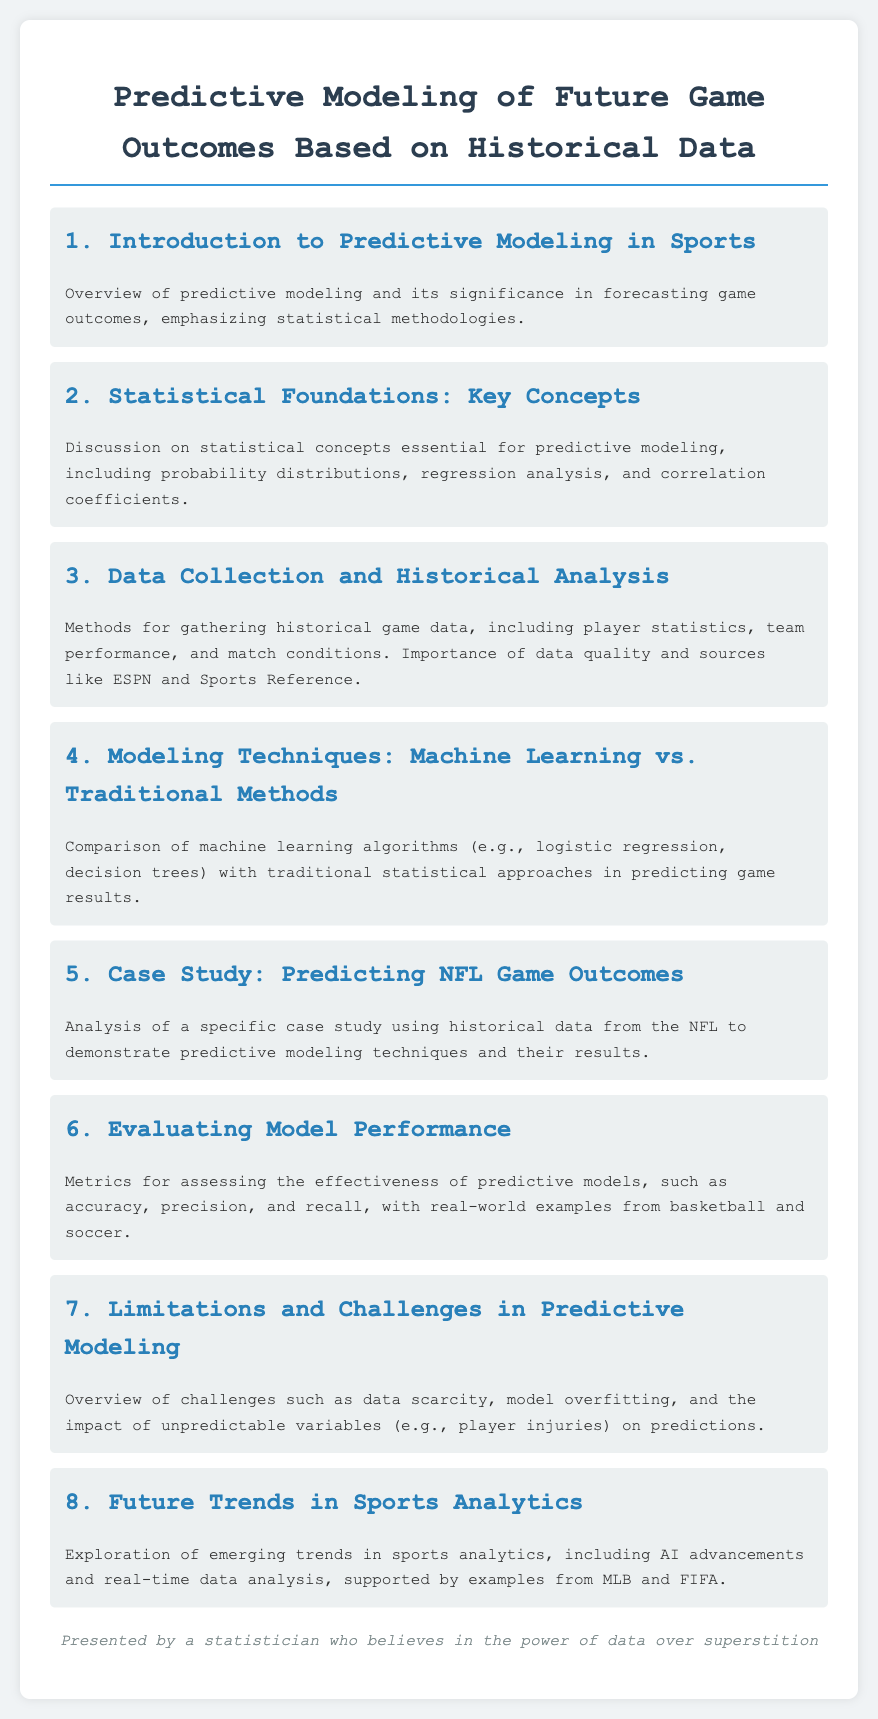What is the title of the document? The title of the document is presented at the top of the rendered HTML, summarizing the main focus of the content.
Answer: Predictive Modeling of Future Game Outcomes Based on Historical Data How many agenda items are listed? The number of agenda items can be counted from the individual sections highlighted within the document.
Answer: 8 What is the focus of agenda item 4? The content of agenda item 4 discusses the comparison of various modeling techniques for predicting game results.
Answer: Modeling Techniques: Machine Learning vs. Traditional Methods What statistical concept is mentioned in agenda item 2? Agenda item 2 covers essential statistical concepts, identifying specific elements relevant to predictive modeling.
Answer: Probability distributions What is the primary challenge noted in agenda item 7? Agenda item 7 discusses the challenges faced within predictive modeling, focusing on specific issues that can impact outcomes.
Answer: Data scarcity Which sports analytics trend is explored in agenda item 8? The content in agenda item 8 elaborates on emerging trends in the field of sports analytics.
Answer: AI advancements What case study is highlighted in agenda item 5? The case study referenced in agenda item 5 uses historical data from a specific professional sports league for further analysis.
Answer: NFL Game Outcomes What is the role of ESPN in agenda item 3? Agenda item 3 mentions ESPN as one of the key sources for gathering necessary historical game data.
Answer: Data source 